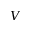Convert formula to latex. <formula><loc_0><loc_0><loc_500><loc_500>V</formula> 